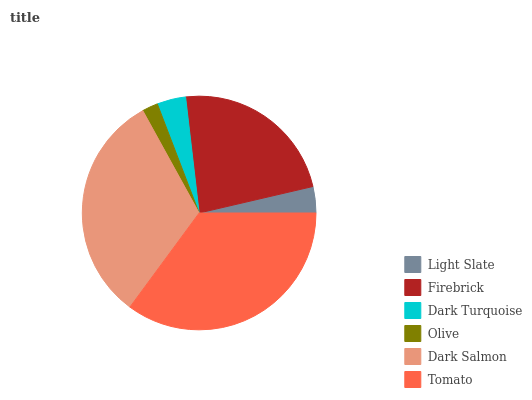Is Olive the minimum?
Answer yes or no. Yes. Is Tomato the maximum?
Answer yes or no. Yes. Is Firebrick the minimum?
Answer yes or no. No. Is Firebrick the maximum?
Answer yes or no. No. Is Firebrick greater than Light Slate?
Answer yes or no. Yes. Is Light Slate less than Firebrick?
Answer yes or no. Yes. Is Light Slate greater than Firebrick?
Answer yes or no. No. Is Firebrick less than Light Slate?
Answer yes or no. No. Is Firebrick the high median?
Answer yes or no. Yes. Is Dark Turquoise the low median?
Answer yes or no. Yes. Is Dark Turquoise the high median?
Answer yes or no. No. Is Dark Salmon the low median?
Answer yes or no. No. 